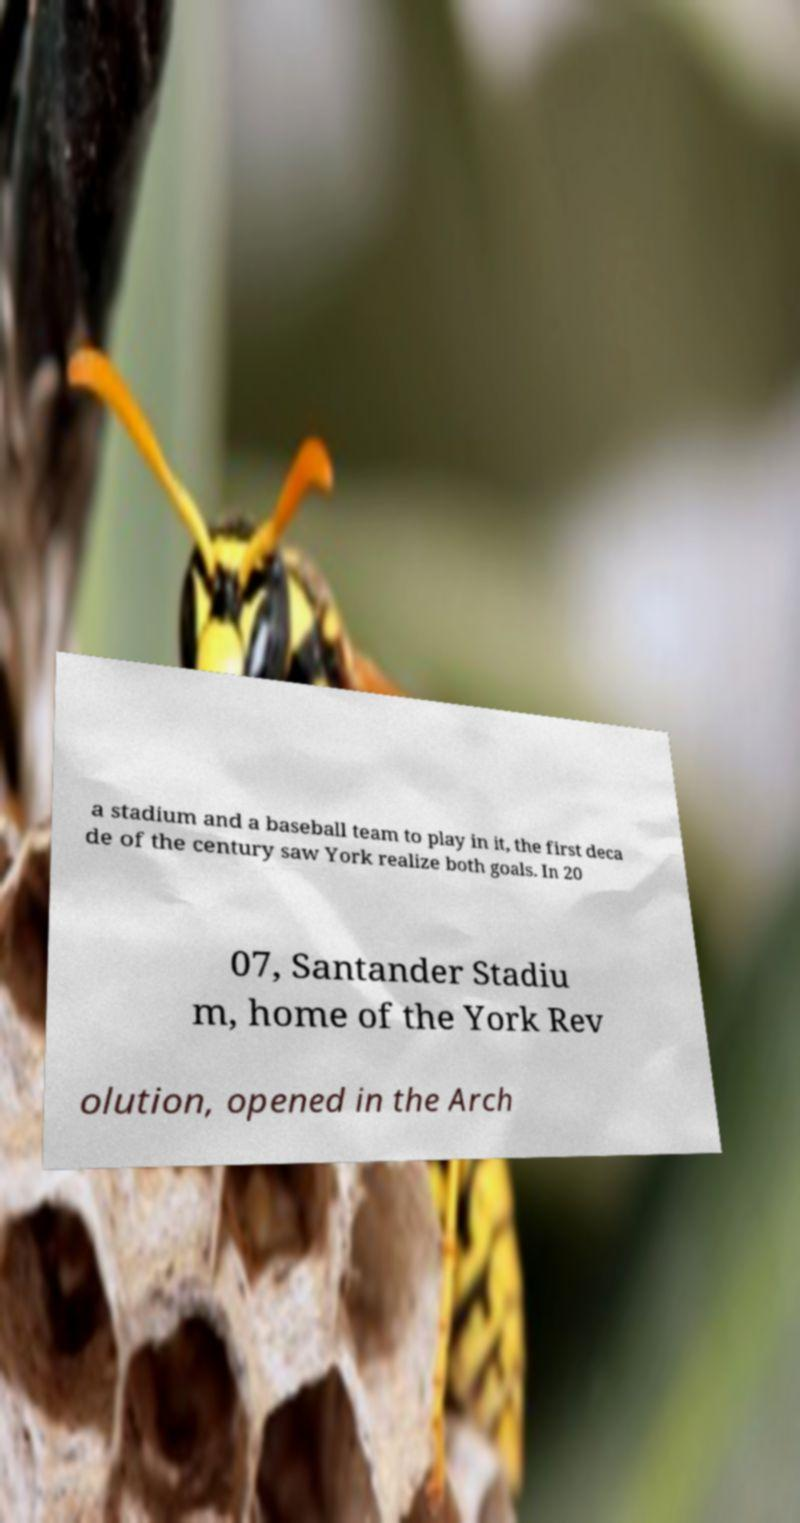For documentation purposes, I need the text within this image transcribed. Could you provide that? a stadium and a baseball team to play in it, the first deca de of the century saw York realize both goals. In 20 07, Santander Stadiu m, home of the York Rev olution, opened in the Arch 